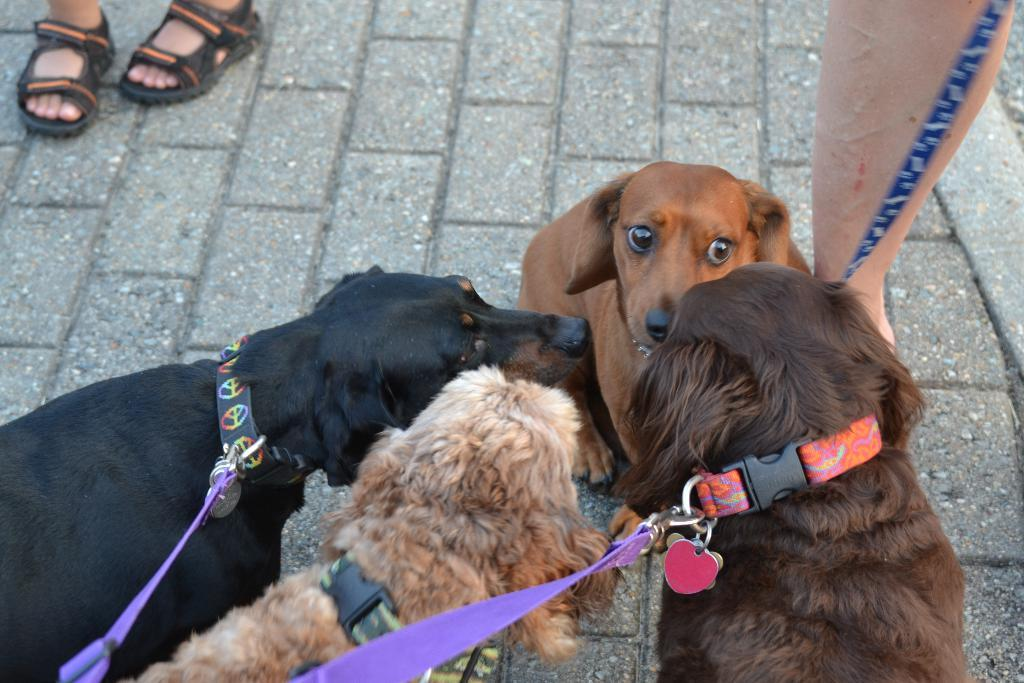What animals are in the center of the image? There are dogs in the center of the image. Can you describe any other elements in the image? The legs of people are visible in the image. What type of love can be seen between the dogs in the image? There is no indication of love between the dogs in the image; they are simply present in the center. 